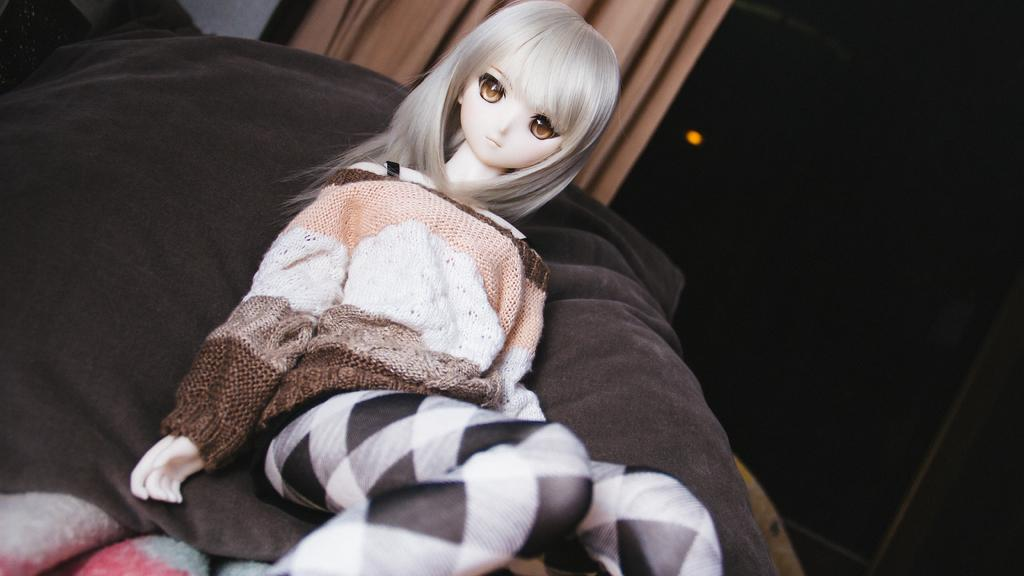What is the main subject in the image? There is a doll in the image. What material is present in the image? There is cloth in the image. What type of covering is visible in the image? There is a curtain in the image. What source of illumination is present in the image? There is a light in the image. Can you describe the objects in the image? There are some objects in the image, but their specific details are not mentioned in the provided facts. What is the color of the background in the image? The background of the image is dark. Can you hear the harmony of the ocean waves in the image? There is no mention of the ocean or any sound in the image, so it is not possible to hear the harmony of ocean waves. 